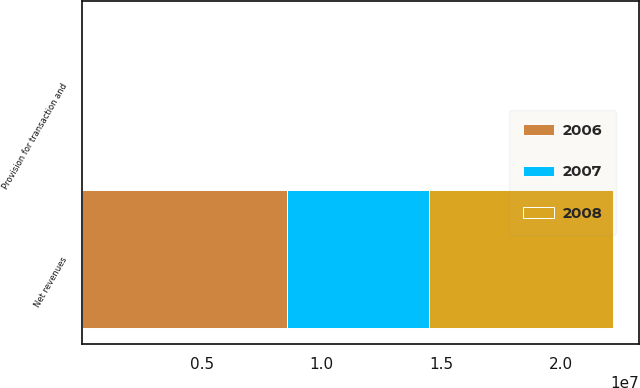<chart> <loc_0><loc_0><loc_500><loc_500><stacked_bar_chart><ecel><fcel>Net revenues<fcel>Provision for transaction and<nl><fcel>2007<fcel>5.96974e+06<fcel>4.5<nl><fcel>2008<fcel>7.67233e+06<fcel>3.8<nl><fcel>2006<fcel>8.54126e+06<fcel>4.1<nl></chart> 